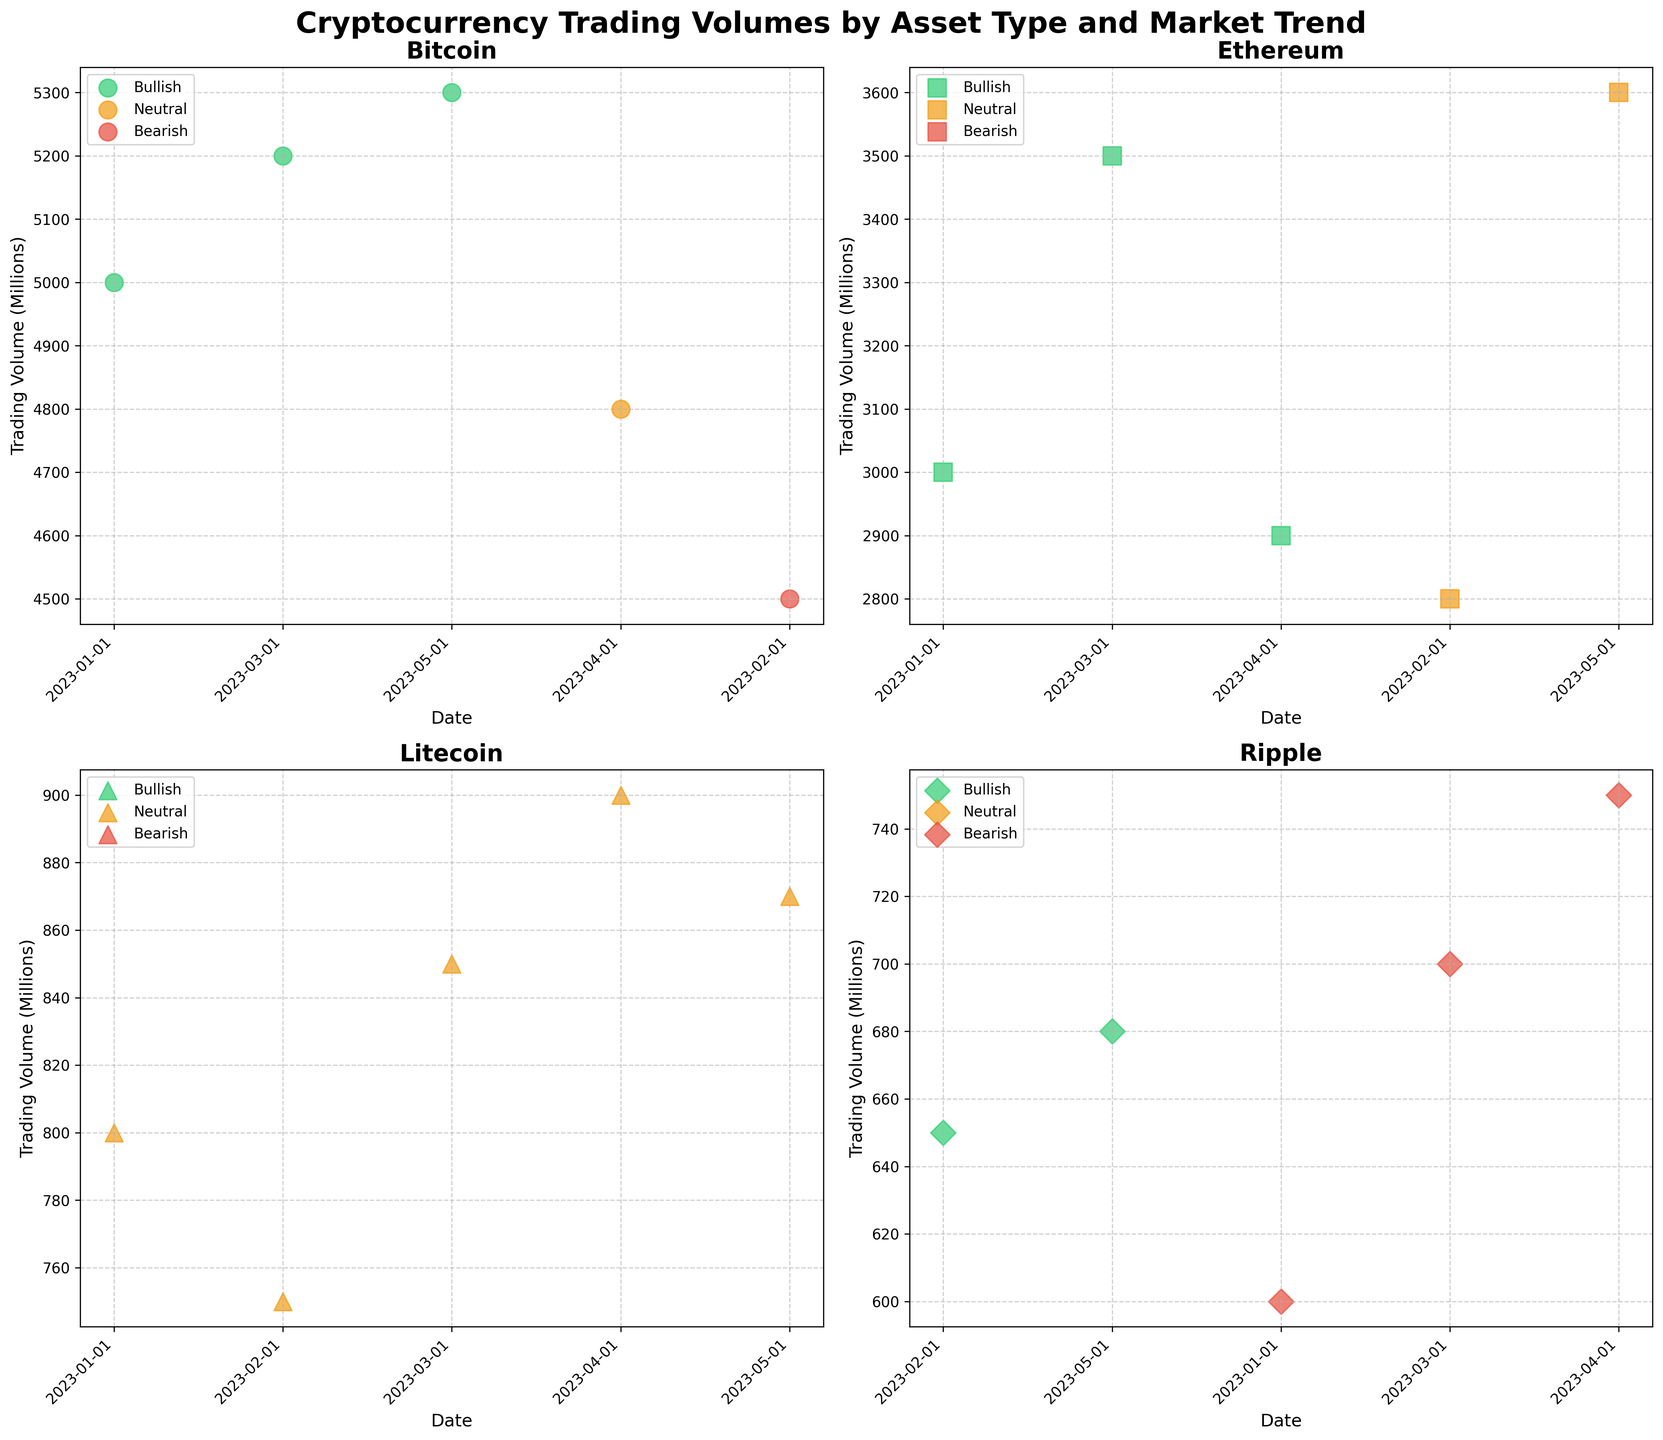What is the title of the figure? The title of the figure can be found at the top center. It should provide a summary of what the figure represents.
Answer: Cryptocurrency Trading Volumes by Asset Type and Market Trend What are the asset types shown in the figure? The asset types are the labels mentioned on each subplot's title. The subplots represent different assets.
Answer: Bitcoin, Ethereum, Litecoin, Ripple How is the bullish market trend represented visually? To identify the visual representation, observe the color legend and markers in the scatter plots.
Answer: Green dots Which asset has the highest trading volume in April 2023? Locate the points corresponding to April 2023 on each subplot and compare their trading volumes.
Answer: Bitcoin Between February 2023 and March 2023, did Bitcoin's trading volume increase or decrease? Check the position of Bitcoin's data points for February and March, and observe the vertical axis values.
Answer: Increase Which market trend does Ethereum predominantly show in the figure? Assess the color of the majority of Ethereum's data points to infer the dominant trend.
Answer: Bullish Comparing the trading volume of Ripple and Litecoin in May 2023, which one is higher? Look at the points representing May 2023 in the Ripple and Litecoin subplots and compare their vertical positions.
Answer: Litecoin Which month shows all the assets experiencing a neutral market trend? Examine each subplot and the color of the data points for each month, checking for neutrality.
Answer: None What is the overall trend observed in Bitcoin's trading volume from January to May 2023? Follow Bitcoin's data points from January to May, noting the general direction of the trading volume values.
Answer: Upward trend How many total data points are plotted across all subplots? Count the number of data points displayed in each subplot and sum them up.
Answer: 20 